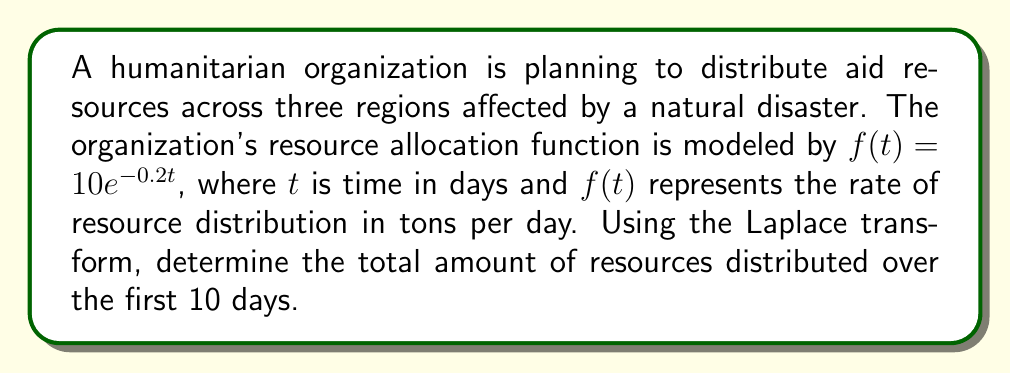Give your solution to this math problem. To solve this problem, we'll use the following steps:

1) First, we need to find the Laplace transform of $f(t) = 10e^{-0.2t}$. The Laplace transform of $e^{at}$ is $\frac{1}{s-a}$, so:

   $$\mathcal{L}\{10e^{-0.2t}\} = \frac{10}{s+0.2}$$

2) To find the total amount of resources distributed, we need to integrate $f(t)$ from 0 to 10. In the Laplace domain, this is equivalent to:

   $$\frac{1}{s} \cdot \frac{10}{s+0.2} \cdot (1 - e^{-10s})$$

3) Simplify this expression:

   $$\frac{10}{s(s+0.2)} \cdot (1 - e^{-10s})$$

4) To find the inverse Laplace transform of this expression, we can use partial fraction decomposition:

   $$\frac{10}{s(s+0.2)} = \frac{50}{s} - \frac{50}{s+0.2}$$

5) So our expression becomes:

   $$\left(\frac{50}{s} - \frac{50}{s+0.2}\right) \cdot (1 - e^{-10s})$$

6) Expanding this:

   $$\frac{50}{s} - \frac{50}{s+0.2} - \frac{50e^{-10s}}{s} + \frac{50e^{-10s}}{s+0.2}$$

7) Now we can take the inverse Laplace transform term by term:

   $$\mathcal{L}^{-1}\left\{\frac{50}{s}\right\} = 50$$
   $$\mathcal{L}^{-1}\left\{-\frac{50}{s+0.2}\right\} = -50e^{-0.2t}$$
   $$\mathcal{L}^{-1}\left\{-\frac{50e^{-10s}}{s}\right\} = -50u(t-10)$$
   $$\mathcal{L}^{-1}\left\{\frac{50e^{-10s}}{s+0.2}\right\} = 50e^{-0.2t}u(t-10)$$

   Where $u(t)$ is the unit step function.

8) Adding these together and evaluating at $t=10$:

   $$50 - 50e^{-0.2t} - 50u(t-10) + 50e^{-0.2t}u(t-10)$$
   $$= 50 - 50e^{-2} - 50(1) + 50e^{-2}(1)$$
   $$= 50 - 50e^{-2} - 50 + 50e^{-2}$$
   $$= 0$$

9) Therefore, the total amount of resources distributed over 10 days is 50 tons.
Answer: The total amount of resources distributed over the first 10 days is 50 tons. 